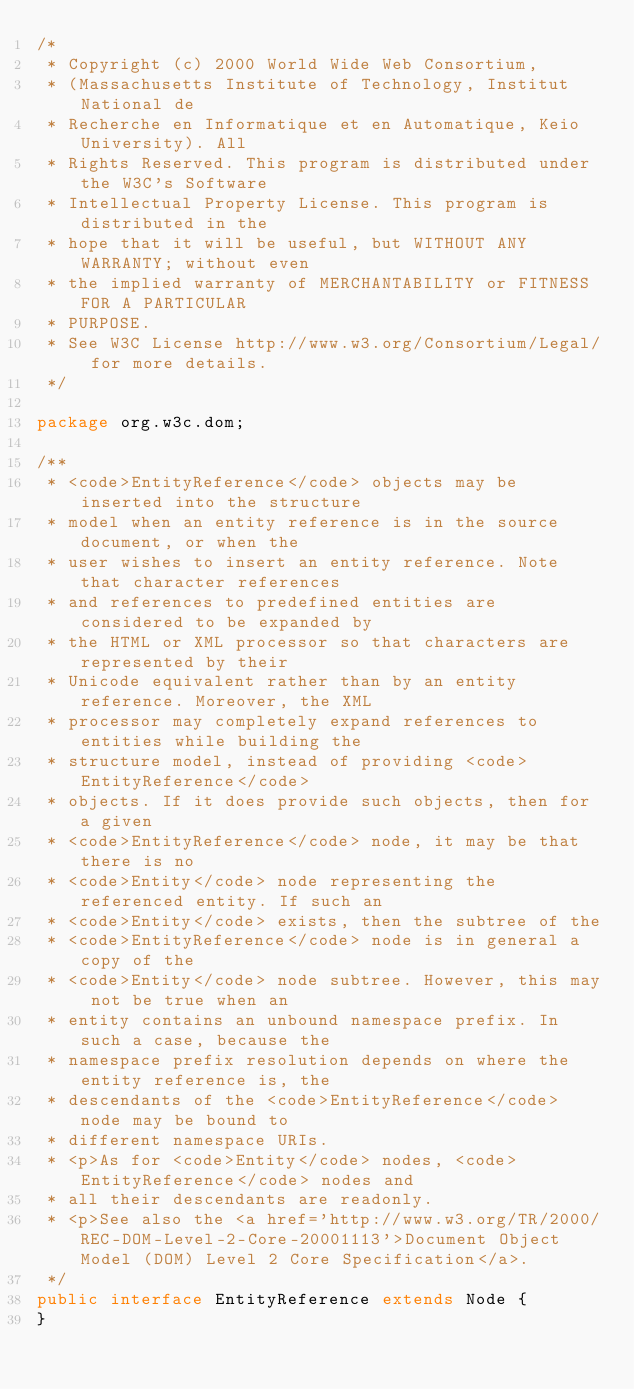<code> <loc_0><loc_0><loc_500><loc_500><_Java_>/*
 * Copyright (c) 2000 World Wide Web Consortium,
 * (Massachusetts Institute of Technology, Institut National de
 * Recherche en Informatique et en Automatique, Keio University). All
 * Rights Reserved. This program is distributed under the W3C's Software
 * Intellectual Property License. This program is distributed in the
 * hope that it will be useful, but WITHOUT ANY WARRANTY; without even
 * the implied warranty of MERCHANTABILITY or FITNESS FOR A PARTICULAR
 * PURPOSE.
 * See W3C License http://www.w3.org/Consortium/Legal/ for more details.
 */

package org.w3c.dom;

/**
 * <code>EntityReference</code> objects may be inserted into the structure 
 * model when an entity reference is in the source document, or when the 
 * user wishes to insert an entity reference. Note that character references 
 * and references to predefined entities are considered to be expanded by 
 * the HTML or XML processor so that characters are represented by their 
 * Unicode equivalent rather than by an entity reference. Moreover, the XML 
 * processor may completely expand references to entities while building the 
 * structure model, instead of providing <code>EntityReference</code> 
 * objects. If it does provide such objects, then for a given 
 * <code>EntityReference</code> node, it may be that there is no 
 * <code>Entity</code> node representing the referenced entity. If such an 
 * <code>Entity</code> exists, then the subtree of the 
 * <code>EntityReference</code> node is in general a copy of the 
 * <code>Entity</code> node subtree. However, this may not be true when an 
 * entity contains an unbound namespace prefix. In such a case, because the 
 * namespace prefix resolution depends on where the entity reference is, the 
 * descendants of the <code>EntityReference</code> node may be bound to 
 * different namespace URIs.
 * <p>As for <code>Entity</code> nodes, <code>EntityReference</code> nodes and 
 * all their descendants are readonly.
 * <p>See also the <a href='http://www.w3.org/TR/2000/REC-DOM-Level-2-Core-20001113'>Document Object Model (DOM) Level 2 Core Specification</a>.
 */
public interface EntityReference extends Node {
}
</code> 